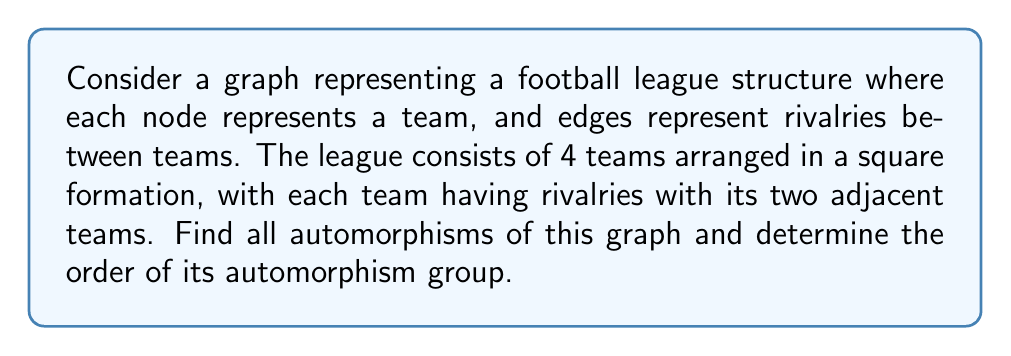Solve this math problem. Let's approach this step-by-step:

1) First, let's visualize the graph:

[asy]
unitsize(1cm);
pair A=(0,0), B=(2,0), C=(2,2), D=(0,2);
draw(A--B--C--D--A);
dot(A); dot(B); dot(C); dot(D);
label("A", A, SW);
label("B", B, SE);
label("C", C, NE);
label("D", D, NW);
[/asy]

2) An automorphism of a graph is a permutation of its vertices that preserves adjacency. In other words, if two vertices are connected by an edge, their images under the automorphism must also be connected by an edge.

3) For this square graph, we can have the following automorphisms:

   - Identity: $(A)(B)(C)(D)$
   - 90° rotation clockwise: $(ABCD)$
   - 180° rotation: $(AC)(BD)$
   - 270° rotation clockwise (90° counterclockwise): $(ADCB)$
   - Reflection about vertical axis: $(AB)(CD)$
   - Reflection about horizontal axis: $(AD)(BC)$
   - Reflection about diagonal (A-C): $(B)(D)(AC)$
   - Reflection about diagonal (B-D): $(A)(C)(BD)$

4) To verify these are all possible automorphisms, note that:
   - A must map to a vertex of degree 2 (A, B, C, or D)
   - Once A's image is chosen, B must map to an adjacent vertex
   - This determines the entire automorphism

5) The automorphism group of this graph is isomorphic to the dihedral group $D_4$, which has order 8.

Therefore, there are 8 automorphisms in total, and the order of the automorphism group is 8.
Answer: The graph has 8 automorphisms: $(A)(B)(C)(D)$, $(ABCD)$, $(AC)(BD)$, $(ADCB)$, $(AB)(CD)$, $(AD)(BC)$, $(B)(D)(AC)$, and $(A)(C)(BD)$. The order of its automorphism group is 8. 